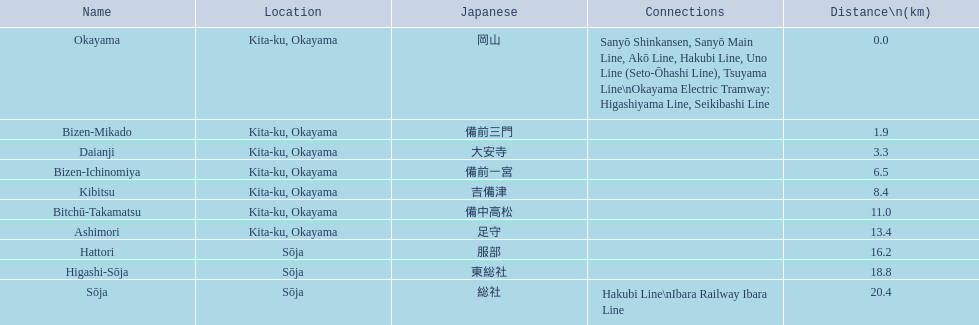Which spans a distance greater than 1 kilometer but lesser than 2 kilometers? Bizen-Mikado. 